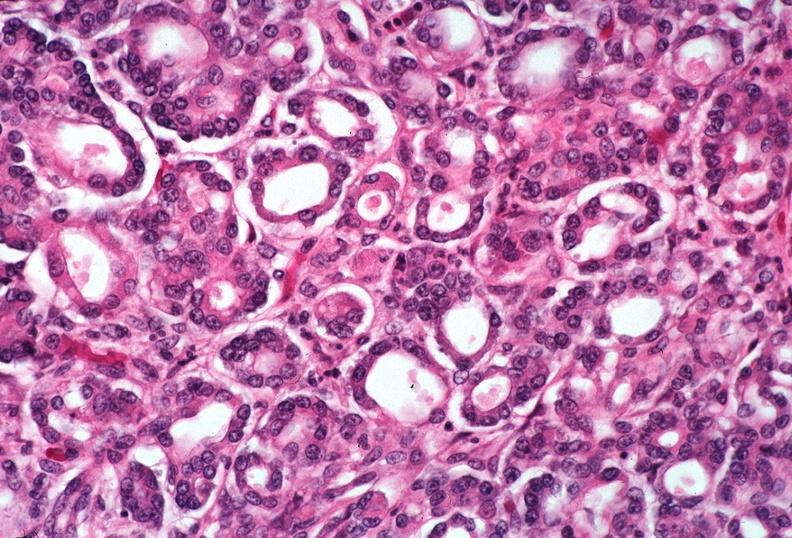why does this image show pancreas, uremic pancreatitis?
Answer the question using a single word or phrase. Due to polycystic kidney 